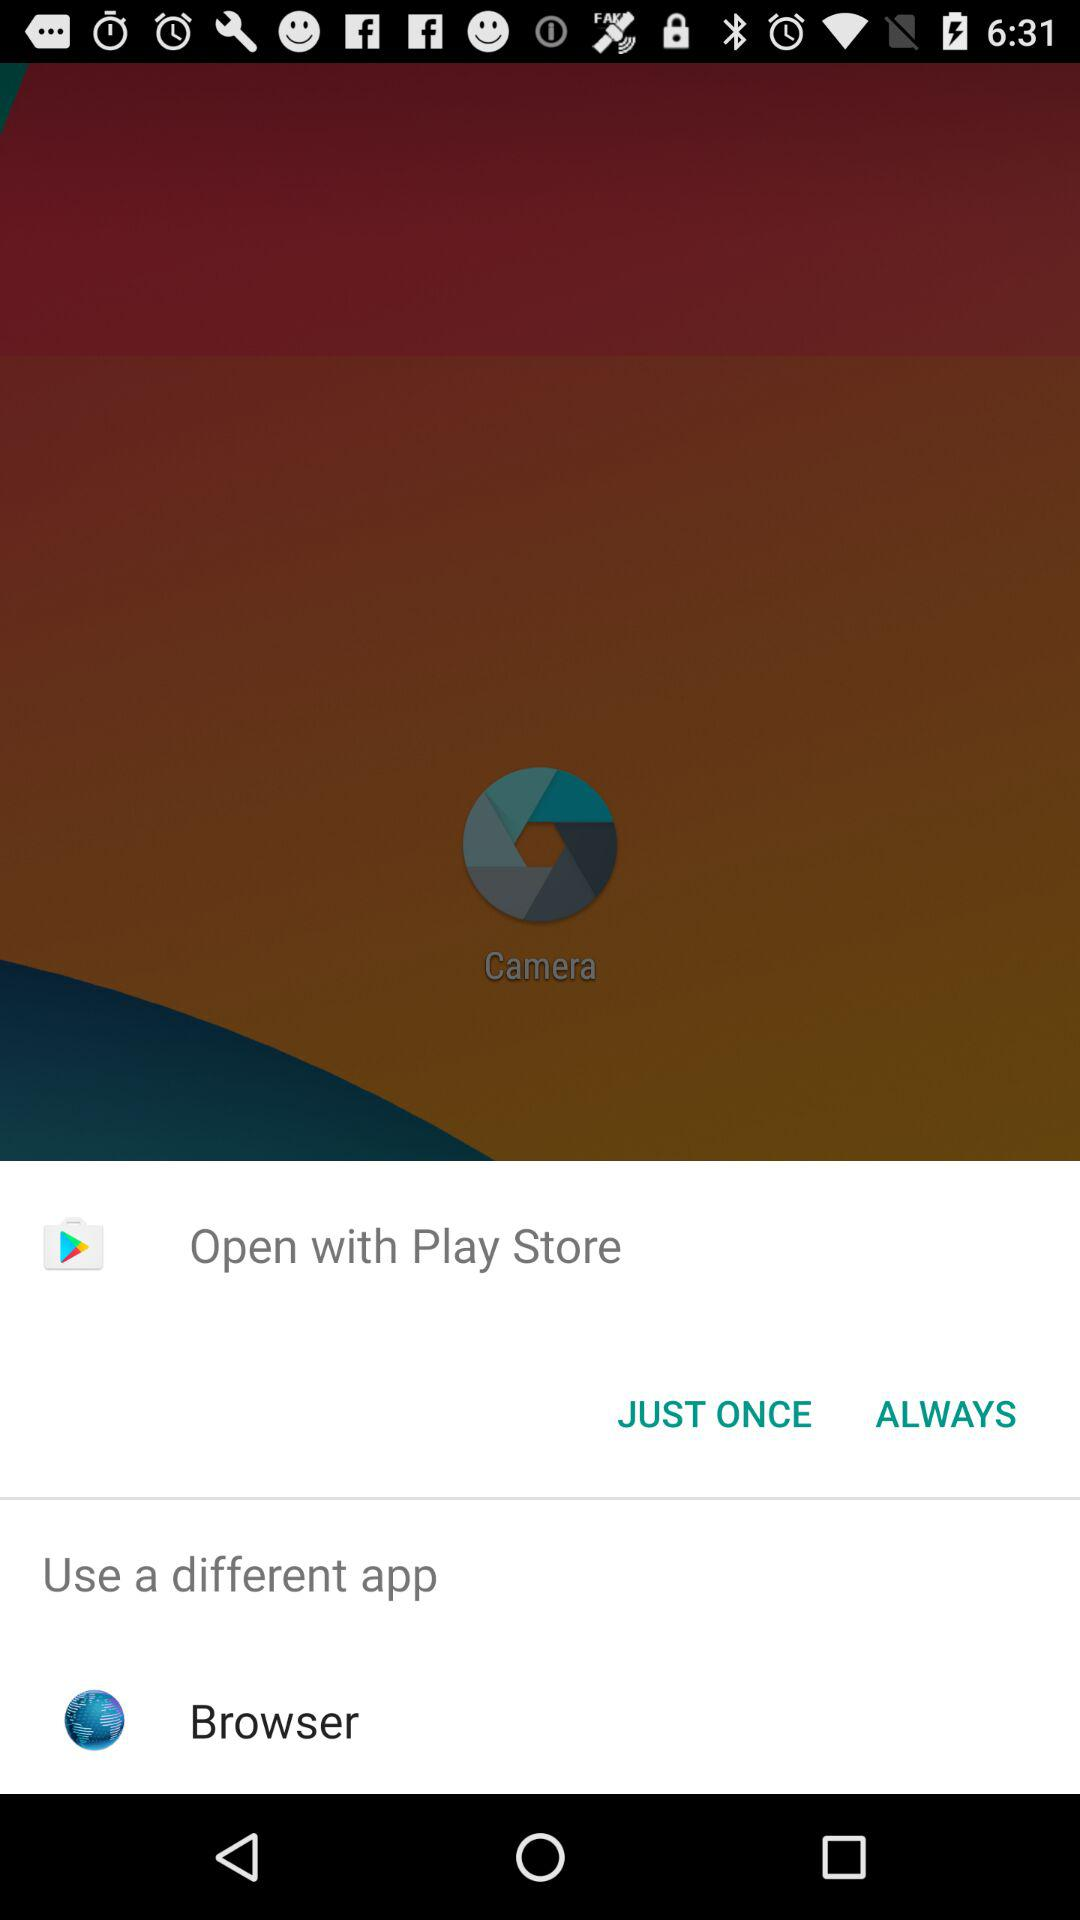What application is given to open with it? You can open it with the "Play Store" and "Browser". 